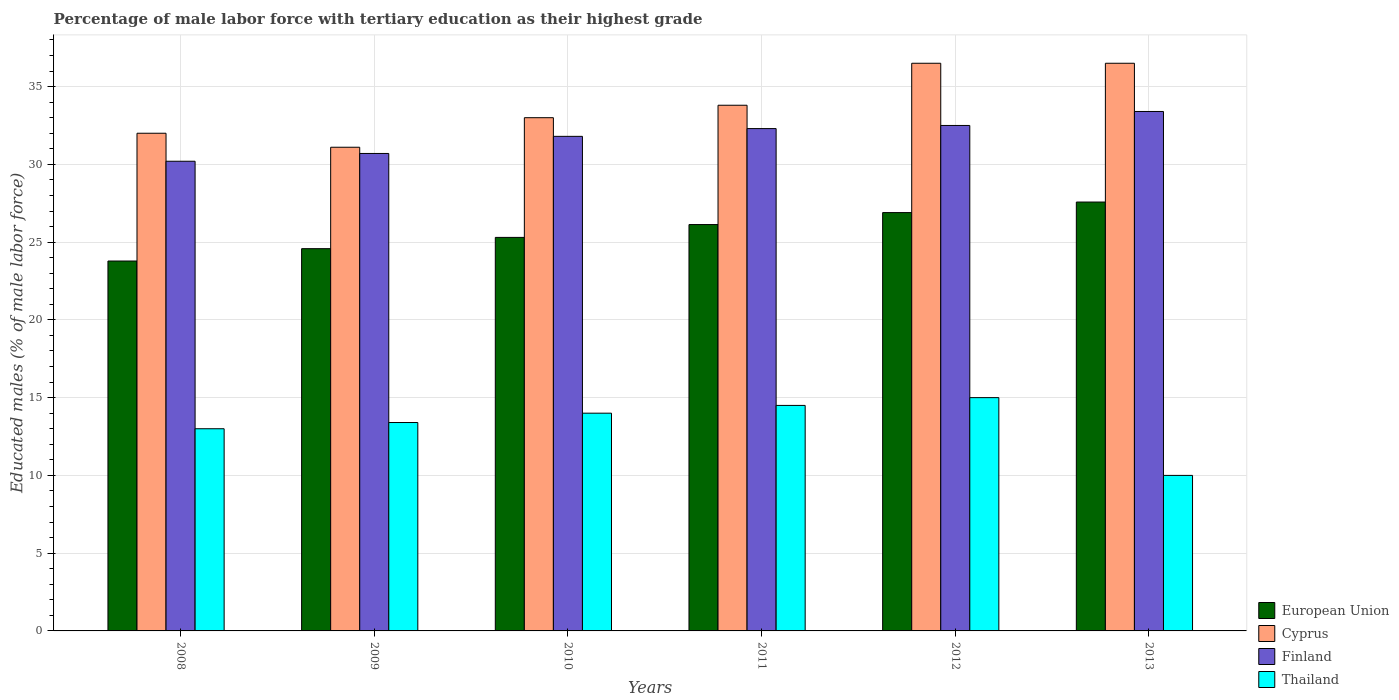How many different coloured bars are there?
Ensure brevity in your answer.  4. How many groups of bars are there?
Keep it short and to the point. 6. How many bars are there on the 1st tick from the left?
Give a very brief answer. 4. What is the percentage of male labor force with tertiary education in European Union in 2013?
Keep it short and to the point. 27.58. Across all years, what is the maximum percentage of male labor force with tertiary education in Cyprus?
Keep it short and to the point. 36.5. Across all years, what is the minimum percentage of male labor force with tertiary education in Finland?
Provide a succinct answer. 30.2. In which year was the percentage of male labor force with tertiary education in European Union minimum?
Give a very brief answer. 2008. What is the total percentage of male labor force with tertiary education in Thailand in the graph?
Keep it short and to the point. 79.9. What is the difference between the percentage of male labor force with tertiary education in Finland in 2008 and that in 2012?
Your response must be concise. -2.3. What is the difference between the percentage of male labor force with tertiary education in European Union in 2011 and the percentage of male labor force with tertiary education in Finland in 2008?
Offer a terse response. -4.07. What is the average percentage of male labor force with tertiary education in Thailand per year?
Provide a short and direct response. 13.32. In the year 2012, what is the difference between the percentage of male labor force with tertiary education in Cyprus and percentage of male labor force with tertiary education in Finland?
Offer a terse response. 4. What is the ratio of the percentage of male labor force with tertiary education in Cyprus in 2009 to that in 2013?
Your answer should be compact. 0.85. Is the percentage of male labor force with tertiary education in Finland in 2011 less than that in 2012?
Give a very brief answer. Yes. Is the difference between the percentage of male labor force with tertiary education in Cyprus in 2010 and 2011 greater than the difference between the percentage of male labor force with tertiary education in Finland in 2010 and 2011?
Offer a terse response. No. What is the difference between the highest and the second highest percentage of male labor force with tertiary education in Finland?
Your answer should be very brief. 0.9. What is the difference between the highest and the lowest percentage of male labor force with tertiary education in European Union?
Your answer should be very brief. 3.79. In how many years, is the percentage of male labor force with tertiary education in Thailand greater than the average percentage of male labor force with tertiary education in Thailand taken over all years?
Offer a very short reply. 4. What does the 4th bar from the left in 2012 represents?
Your response must be concise. Thailand. What does the 2nd bar from the right in 2010 represents?
Your response must be concise. Finland. Is it the case that in every year, the sum of the percentage of male labor force with tertiary education in Cyprus and percentage of male labor force with tertiary education in Thailand is greater than the percentage of male labor force with tertiary education in Finland?
Give a very brief answer. Yes. Are all the bars in the graph horizontal?
Your answer should be compact. No. Where does the legend appear in the graph?
Your response must be concise. Bottom right. How many legend labels are there?
Provide a short and direct response. 4. What is the title of the graph?
Offer a terse response. Percentage of male labor force with tertiary education as their highest grade. Does "Denmark" appear as one of the legend labels in the graph?
Your answer should be compact. No. What is the label or title of the X-axis?
Give a very brief answer. Years. What is the label or title of the Y-axis?
Your answer should be compact. Educated males (% of male labor force). What is the Educated males (% of male labor force) of European Union in 2008?
Give a very brief answer. 23.78. What is the Educated males (% of male labor force) in Cyprus in 2008?
Your answer should be compact. 32. What is the Educated males (% of male labor force) of Finland in 2008?
Make the answer very short. 30.2. What is the Educated males (% of male labor force) of European Union in 2009?
Give a very brief answer. 24.58. What is the Educated males (% of male labor force) in Cyprus in 2009?
Provide a short and direct response. 31.1. What is the Educated males (% of male labor force) in Finland in 2009?
Make the answer very short. 30.7. What is the Educated males (% of male labor force) in Thailand in 2009?
Provide a short and direct response. 13.4. What is the Educated males (% of male labor force) in European Union in 2010?
Keep it short and to the point. 25.3. What is the Educated males (% of male labor force) of Cyprus in 2010?
Offer a terse response. 33. What is the Educated males (% of male labor force) of Finland in 2010?
Provide a short and direct response. 31.8. What is the Educated males (% of male labor force) in Thailand in 2010?
Give a very brief answer. 14. What is the Educated males (% of male labor force) of European Union in 2011?
Your answer should be compact. 26.13. What is the Educated males (% of male labor force) in Cyprus in 2011?
Your answer should be compact. 33.8. What is the Educated males (% of male labor force) of Finland in 2011?
Keep it short and to the point. 32.3. What is the Educated males (% of male labor force) in European Union in 2012?
Offer a very short reply. 26.9. What is the Educated males (% of male labor force) in Cyprus in 2012?
Ensure brevity in your answer.  36.5. What is the Educated males (% of male labor force) of Finland in 2012?
Provide a short and direct response. 32.5. What is the Educated males (% of male labor force) in Thailand in 2012?
Offer a very short reply. 15. What is the Educated males (% of male labor force) in European Union in 2013?
Offer a very short reply. 27.58. What is the Educated males (% of male labor force) of Cyprus in 2013?
Make the answer very short. 36.5. What is the Educated males (% of male labor force) of Finland in 2013?
Offer a very short reply. 33.4. What is the Educated males (% of male labor force) of Thailand in 2013?
Ensure brevity in your answer.  10. Across all years, what is the maximum Educated males (% of male labor force) of European Union?
Provide a succinct answer. 27.58. Across all years, what is the maximum Educated males (% of male labor force) in Cyprus?
Offer a terse response. 36.5. Across all years, what is the maximum Educated males (% of male labor force) of Finland?
Make the answer very short. 33.4. Across all years, what is the maximum Educated males (% of male labor force) in Thailand?
Provide a succinct answer. 15. Across all years, what is the minimum Educated males (% of male labor force) in European Union?
Make the answer very short. 23.78. Across all years, what is the minimum Educated males (% of male labor force) in Cyprus?
Offer a terse response. 31.1. Across all years, what is the minimum Educated males (% of male labor force) in Finland?
Provide a short and direct response. 30.2. What is the total Educated males (% of male labor force) of European Union in the graph?
Give a very brief answer. 154.27. What is the total Educated males (% of male labor force) of Cyprus in the graph?
Provide a short and direct response. 202.9. What is the total Educated males (% of male labor force) of Finland in the graph?
Your answer should be very brief. 190.9. What is the total Educated males (% of male labor force) of Thailand in the graph?
Your answer should be very brief. 79.9. What is the difference between the Educated males (% of male labor force) in European Union in 2008 and that in 2009?
Offer a terse response. -0.79. What is the difference between the Educated males (% of male labor force) in Cyprus in 2008 and that in 2009?
Your response must be concise. 0.9. What is the difference between the Educated males (% of male labor force) of Finland in 2008 and that in 2009?
Your answer should be compact. -0.5. What is the difference between the Educated males (% of male labor force) of Thailand in 2008 and that in 2009?
Offer a very short reply. -0.4. What is the difference between the Educated males (% of male labor force) of European Union in 2008 and that in 2010?
Your answer should be very brief. -1.52. What is the difference between the Educated males (% of male labor force) in Thailand in 2008 and that in 2010?
Your response must be concise. -1. What is the difference between the Educated males (% of male labor force) of European Union in 2008 and that in 2011?
Your response must be concise. -2.34. What is the difference between the Educated males (% of male labor force) of European Union in 2008 and that in 2012?
Offer a very short reply. -3.11. What is the difference between the Educated males (% of male labor force) in Cyprus in 2008 and that in 2012?
Offer a very short reply. -4.5. What is the difference between the Educated males (% of male labor force) of European Union in 2008 and that in 2013?
Your response must be concise. -3.79. What is the difference between the Educated males (% of male labor force) in Thailand in 2008 and that in 2013?
Offer a terse response. 3. What is the difference between the Educated males (% of male labor force) of European Union in 2009 and that in 2010?
Give a very brief answer. -0.72. What is the difference between the Educated males (% of male labor force) in Finland in 2009 and that in 2010?
Your answer should be compact. -1.1. What is the difference between the Educated males (% of male labor force) in Thailand in 2009 and that in 2010?
Your answer should be very brief. -0.6. What is the difference between the Educated males (% of male labor force) of European Union in 2009 and that in 2011?
Ensure brevity in your answer.  -1.55. What is the difference between the Educated males (% of male labor force) of Cyprus in 2009 and that in 2011?
Your answer should be very brief. -2.7. What is the difference between the Educated males (% of male labor force) in Finland in 2009 and that in 2011?
Offer a terse response. -1.6. What is the difference between the Educated males (% of male labor force) of European Union in 2009 and that in 2012?
Ensure brevity in your answer.  -2.32. What is the difference between the Educated males (% of male labor force) in Cyprus in 2009 and that in 2012?
Provide a succinct answer. -5.4. What is the difference between the Educated males (% of male labor force) in Finland in 2009 and that in 2012?
Your answer should be very brief. -1.8. What is the difference between the Educated males (% of male labor force) of Thailand in 2009 and that in 2012?
Offer a very short reply. -1.6. What is the difference between the Educated males (% of male labor force) in European Union in 2009 and that in 2013?
Provide a short and direct response. -3. What is the difference between the Educated males (% of male labor force) in European Union in 2010 and that in 2011?
Give a very brief answer. -0.83. What is the difference between the Educated males (% of male labor force) of Finland in 2010 and that in 2011?
Your answer should be compact. -0.5. What is the difference between the Educated males (% of male labor force) in Thailand in 2010 and that in 2011?
Ensure brevity in your answer.  -0.5. What is the difference between the Educated males (% of male labor force) in European Union in 2010 and that in 2012?
Offer a terse response. -1.6. What is the difference between the Educated males (% of male labor force) in Cyprus in 2010 and that in 2012?
Your response must be concise. -3.5. What is the difference between the Educated males (% of male labor force) of Finland in 2010 and that in 2012?
Your answer should be very brief. -0.7. What is the difference between the Educated males (% of male labor force) of Thailand in 2010 and that in 2012?
Your answer should be very brief. -1. What is the difference between the Educated males (% of male labor force) of European Union in 2010 and that in 2013?
Make the answer very short. -2.27. What is the difference between the Educated males (% of male labor force) in Cyprus in 2010 and that in 2013?
Offer a terse response. -3.5. What is the difference between the Educated males (% of male labor force) of European Union in 2011 and that in 2012?
Your answer should be compact. -0.77. What is the difference between the Educated males (% of male labor force) of Finland in 2011 and that in 2012?
Your response must be concise. -0.2. What is the difference between the Educated males (% of male labor force) of European Union in 2011 and that in 2013?
Provide a short and direct response. -1.45. What is the difference between the Educated males (% of male labor force) in Finland in 2011 and that in 2013?
Give a very brief answer. -1.1. What is the difference between the Educated males (% of male labor force) in European Union in 2012 and that in 2013?
Your response must be concise. -0.68. What is the difference between the Educated males (% of male labor force) of Cyprus in 2012 and that in 2013?
Give a very brief answer. 0. What is the difference between the Educated males (% of male labor force) in Finland in 2012 and that in 2013?
Ensure brevity in your answer.  -0.9. What is the difference between the Educated males (% of male labor force) of European Union in 2008 and the Educated males (% of male labor force) of Cyprus in 2009?
Keep it short and to the point. -7.32. What is the difference between the Educated males (% of male labor force) of European Union in 2008 and the Educated males (% of male labor force) of Finland in 2009?
Your answer should be very brief. -6.92. What is the difference between the Educated males (% of male labor force) in European Union in 2008 and the Educated males (% of male labor force) in Thailand in 2009?
Your answer should be very brief. 10.38. What is the difference between the Educated males (% of male labor force) of Finland in 2008 and the Educated males (% of male labor force) of Thailand in 2009?
Ensure brevity in your answer.  16.8. What is the difference between the Educated males (% of male labor force) of European Union in 2008 and the Educated males (% of male labor force) of Cyprus in 2010?
Give a very brief answer. -9.22. What is the difference between the Educated males (% of male labor force) of European Union in 2008 and the Educated males (% of male labor force) of Finland in 2010?
Provide a short and direct response. -8.02. What is the difference between the Educated males (% of male labor force) in European Union in 2008 and the Educated males (% of male labor force) in Thailand in 2010?
Your response must be concise. 9.78. What is the difference between the Educated males (% of male labor force) in Cyprus in 2008 and the Educated males (% of male labor force) in Finland in 2010?
Offer a terse response. 0.2. What is the difference between the Educated males (% of male labor force) in Cyprus in 2008 and the Educated males (% of male labor force) in Thailand in 2010?
Your answer should be compact. 18. What is the difference between the Educated males (% of male labor force) of Finland in 2008 and the Educated males (% of male labor force) of Thailand in 2010?
Give a very brief answer. 16.2. What is the difference between the Educated males (% of male labor force) of European Union in 2008 and the Educated males (% of male labor force) of Cyprus in 2011?
Ensure brevity in your answer.  -10.02. What is the difference between the Educated males (% of male labor force) in European Union in 2008 and the Educated males (% of male labor force) in Finland in 2011?
Give a very brief answer. -8.52. What is the difference between the Educated males (% of male labor force) of European Union in 2008 and the Educated males (% of male labor force) of Thailand in 2011?
Your response must be concise. 9.28. What is the difference between the Educated males (% of male labor force) in Cyprus in 2008 and the Educated males (% of male labor force) in Finland in 2011?
Your answer should be very brief. -0.3. What is the difference between the Educated males (% of male labor force) in Cyprus in 2008 and the Educated males (% of male labor force) in Thailand in 2011?
Your answer should be compact. 17.5. What is the difference between the Educated males (% of male labor force) of Finland in 2008 and the Educated males (% of male labor force) of Thailand in 2011?
Ensure brevity in your answer.  15.7. What is the difference between the Educated males (% of male labor force) in European Union in 2008 and the Educated males (% of male labor force) in Cyprus in 2012?
Your answer should be compact. -12.72. What is the difference between the Educated males (% of male labor force) of European Union in 2008 and the Educated males (% of male labor force) of Finland in 2012?
Your response must be concise. -8.72. What is the difference between the Educated males (% of male labor force) of European Union in 2008 and the Educated males (% of male labor force) of Thailand in 2012?
Offer a terse response. 8.78. What is the difference between the Educated males (% of male labor force) in Finland in 2008 and the Educated males (% of male labor force) in Thailand in 2012?
Your answer should be compact. 15.2. What is the difference between the Educated males (% of male labor force) of European Union in 2008 and the Educated males (% of male labor force) of Cyprus in 2013?
Your answer should be very brief. -12.72. What is the difference between the Educated males (% of male labor force) in European Union in 2008 and the Educated males (% of male labor force) in Finland in 2013?
Provide a succinct answer. -9.62. What is the difference between the Educated males (% of male labor force) of European Union in 2008 and the Educated males (% of male labor force) of Thailand in 2013?
Ensure brevity in your answer.  13.78. What is the difference between the Educated males (% of male labor force) of Cyprus in 2008 and the Educated males (% of male labor force) of Finland in 2013?
Ensure brevity in your answer.  -1.4. What is the difference between the Educated males (% of male labor force) in Cyprus in 2008 and the Educated males (% of male labor force) in Thailand in 2013?
Your answer should be compact. 22. What is the difference between the Educated males (% of male labor force) in Finland in 2008 and the Educated males (% of male labor force) in Thailand in 2013?
Keep it short and to the point. 20.2. What is the difference between the Educated males (% of male labor force) of European Union in 2009 and the Educated males (% of male labor force) of Cyprus in 2010?
Ensure brevity in your answer.  -8.42. What is the difference between the Educated males (% of male labor force) of European Union in 2009 and the Educated males (% of male labor force) of Finland in 2010?
Give a very brief answer. -7.22. What is the difference between the Educated males (% of male labor force) of European Union in 2009 and the Educated males (% of male labor force) of Thailand in 2010?
Provide a succinct answer. 10.58. What is the difference between the Educated males (% of male labor force) in European Union in 2009 and the Educated males (% of male labor force) in Cyprus in 2011?
Provide a succinct answer. -9.22. What is the difference between the Educated males (% of male labor force) of European Union in 2009 and the Educated males (% of male labor force) of Finland in 2011?
Offer a terse response. -7.72. What is the difference between the Educated males (% of male labor force) of European Union in 2009 and the Educated males (% of male labor force) of Thailand in 2011?
Offer a terse response. 10.08. What is the difference between the Educated males (% of male labor force) of Cyprus in 2009 and the Educated males (% of male labor force) of Thailand in 2011?
Your response must be concise. 16.6. What is the difference between the Educated males (% of male labor force) of Finland in 2009 and the Educated males (% of male labor force) of Thailand in 2011?
Provide a succinct answer. 16.2. What is the difference between the Educated males (% of male labor force) of European Union in 2009 and the Educated males (% of male labor force) of Cyprus in 2012?
Your answer should be compact. -11.92. What is the difference between the Educated males (% of male labor force) in European Union in 2009 and the Educated males (% of male labor force) in Finland in 2012?
Ensure brevity in your answer.  -7.92. What is the difference between the Educated males (% of male labor force) of European Union in 2009 and the Educated males (% of male labor force) of Thailand in 2012?
Provide a short and direct response. 9.58. What is the difference between the Educated males (% of male labor force) of Cyprus in 2009 and the Educated males (% of male labor force) of Finland in 2012?
Provide a short and direct response. -1.4. What is the difference between the Educated males (% of male labor force) of Finland in 2009 and the Educated males (% of male labor force) of Thailand in 2012?
Make the answer very short. 15.7. What is the difference between the Educated males (% of male labor force) in European Union in 2009 and the Educated males (% of male labor force) in Cyprus in 2013?
Keep it short and to the point. -11.92. What is the difference between the Educated males (% of male labor force) of European Union in 2009 and the Educated males (% of male labor force) of Finland in 2013?
Offer a very short reply. -8.82. What is the difference between the Educated males (% of male labor force) in European Union in 2009 and the Educated males (% of male labor force) in Thailand in 2013?
Offer a very short reply. 14.58. What is the difference between the Educated males (% of male labor force) in Cyprus in 2009 and the Educated males (% of male labor force) in Finland in 2013?
Provide a short and direct response. -2.3. What is the difference between the Educated males (% of male labor force) in Cyprus in 2009 and the Educated males (% of male labor force) in Thailand in 2013?
Offer a terse response. 21.1. What is the difference between the Educated males (% of male labor force) of Finland in 2009 and the Educated males (% of male labor force) of Thailand in 2013?
Give a very brief answer. 20.7. What is the difference between the Educated males (% of male labor force) of European Union in 2010 and the Educated males (% of male labor force) of Cyprus in 2011?
Offer a very short reply. -8.5. What is the difference between the Educated males (% of male labor force) in European Union in 2010 and the Educated males (% of male labor force) in Finland in 2011?
Offer a very short reply. -7. What is the difference between the Educated males (% of male labor force) in European Union in 2010 and the Educated males (% of male labor force) in Thailand in 2011?
Your answer should be compact. 10.8. What is the difference between the Educated males (% of male labor force) in Cyprus in 2010 and the Educated males (% of male labor force) in Finland in 2011?
Provide a short and direct response. 0.7. What is the difference between the Educated males (% of male labor force) in Cyprus in 2010 and the Educated males (% of male labor force) in Thailand in 2011?
Offer a very short reply. 18.5. What is the difference between the Educated males (% of male labor force) of Finland in 2010 and the Educated males (% of male labor force) of Thailand in 2011?
Your answer should be compact. 17.3. What is the difference between the Educated males (% of male labor force) in European Union in 2010 and the Educated males (% of male labor force) in Cyprus in 2012?
Your response must be concise. -11.2. What is the difference between the Educated males (% of male labor force) in European Union in 2010 and the Educated males (% of male labor force) in Finland in 2012?
Provide a succinct answer. -7.2. What is the difference between the Educated males (% of male labor force) of European Union in 2010 and the Educated males (% of male labor force) of Thailand in 2012?
Provide a succinct answer. 10.3. What is the difference between the Educated males (% of male labor force) in Cyprus in 2010 and the Educated males (% of male labor force) in Finland in 2012?
Your answer should be very brief. 0.5. What is the difference between the Educated males (% of male labor force) of Finland in 2010 and the Educated males (% of male labor force) of Thailand in 2012?
Give a very brief answer. 16.8. What is the difference between the Educated males (% of male labor force) of European Union in 2010 and the Educated males (% of male labor force) of Cyprus in 2013?
Your response must be concise. -11.2. What is the difference between the Educated males (% of male labor force) of European Union in 2010 and the Educated males (% of male labor force) of Finland in 2013?
Offer a terse response. -8.1. What is the difference between the Educated males (% of male labor force) in European Union in 2010 and the Educated males (% of male labor force) in Thailand in 2013?
Ensure brevity in your answer.  15.3. What is the difference between the Educated males (% of male labor force) of Cyprus in 2010 and the Educated males (% of male labor force) of Finland in 2013?
Keep it short and to the point. -0.4. What is the difference between the Educated males (% of male labor force) in Cyprus in 2010 and the Educated males (% of male labor force) in Thailand in 2013?
Offer a very short reply. 23. What is the difference between the Educated males (% of male labor force) in Finland in 2010 and the Educated males (% of male labor force) in Thailand in 2013?
Give a very brief answer. 21.8. What is the difference between the Educated males (% of male labor force) in European Union in 2011 and the Educated males (% of male labor force) in Cyprus in 2012?
Give a very brief answer. -10.37. What is the difference between the Educated males (% of male labor force) of European Union in 2011 and the Educated males (% of male labor force) of Finland in 2012?
Provide a succinct answer. -6.37. What is the difference between the Educated males (% of male labor force) of European Union in 2011 and the Educated males (% of male labor force) of Thailand in 2012?
Provide a succinct answer. 11.13. What is the difference between the Educated males (% of male labor force) in Cyprus in 2011 and the Educated males (% of male labor force) in Finland in 2012?
Ensure brevity in your answer.  1.3. What is the difference between the Educated males (% of male labor force) of European Union in 2011 and the Educated males (% of male labor force) of Cyprus in 2013?
Your answer should be very brief. -10.37. What is the difference between the Educated males (% of male labor force) of European Union in 2011 and the Educated males (% of male labor force) of Finland in 2013?
Ensure brevity in your answer.  -7.27. What is the difference between the Educated males (% of male labor force) in European Union in 2011 and the Educated males (% of male labor force) in Thailand in 2013?
Offer a very short reply. 16.13. What is the difference between the Educated males (% of male labor force) of Cyprus in 2011 and the Educated males (% of male labor force) of Finland in 2013?
Ensure brevity in your answer.  0.4. What is the difference between the Educated males (% of male labor force) in Cyprus in 2011 and the Educated males (% of male labor force) in Thailand in 2013?
Offer a terse response. 23.8. What is the difference between the Educated males (% of male labor force) in Finland in 2011 and the Educated males (% of male labor force) in Thailand in 2013?
Your response must be concise. 22.3. What is the difference between the Educated males (% of male labor force) in European Union in 2012 and the Educated males (% of male labor force) in Cyprus in 2013?
Your response must be concise. -9.6. What is the difference between the Educated males (% of male labor force) of European Union in 2012 and the Educated males (% of male labor force) of Finland in 2013?
Your answer should be very brief. -6.5. What is the difference between the Educated males (% of male labor force) of European Union in 2012 and the Educated males (% of male labor force) of Thailand in 2013?
Keep it short and to the point. 16.9. What is the difference between the Educated males (% of male labor force) in Cyprus in 2012 and the Educated males (% of male labor force) in Finland in 2013?
Your answer should be very brief. 3.1. What is the difference between the Educated males (% of male labor force) of Finland in 2012 and the Educated males (% of male labor force) of Thailand in 2013?
Give a very brief answer. 22.5. What is the average Educated males (% of male labor force) of European Union per year?
Make the answer very short. 25.71. What is the average Educated males (% of male labor force) in Cyprus per year?
Offer a terse response. 33.82. What is the average Educated males (% of male labor force) in Finland per year?
Provide a succinct answer. 31.82. What is the average Educated males (% of male labor force) of Thailand per year?
Provide a short and direct response. 13.32. In the year 2008, what is the difference between the Educated males (% of male labor force) of European Union and Educated males (% of male labor force) of Cyprus?
Your response must be concise. -8.22. In the year 2008, what is the difference between the Educated males (% of male labor force) of European Union and Educated males (% of male labor force) of Finland?
Provide a short and direct response. -6.42. In the year 2008, what is the difference between the Educated males (% of male labor force) of European Union and Educated males (% of male labor force) of Thailand?
Offer a very short reply. 10.78. In the year 2009, what is the difference between the Educated males (% of male labor force) of European Union and Educated males (% of male labor force) of Cyprus?
Give a very brief answer. -6.52. In the year 2009, what is the difference between the Educated males (% of male labor force) of European Union and Educated males (% of male labor force) of Finland?
Make the answer very short. -6.12. In the year 2009, what is the difference between the Educated males (% of male labor force) of European Union and Educated males (% of male labor force) of Thailand?
Your answer should be very brief. 11.18. In the year 2009, what is the difference between the Educated males (% of male labor force) in Cyprus and Educated males (% of male labor force) in Thailand?
Give a very brief answer. 17.7. In the year 2009, what is the difference between the Educated males (% of male labor force) in Finland and Educated males (% of male labor force) in Thailand?
Ensure brevity in your answer.  17.3. In the year 2010, what is the difference between the Educated males (% of male labor force) in European Union and Educated males (% of male labor force) in Cyprus?
Make the answer very short. -7.7. In the year 2010, what is the difference between the Educated males (% of male labor force) of European Union and Educated males (% of male labor force) of Finland?
Your answer should be very brief. -6.5. In the year 2010, what is the difference between the Educated males (% of male labor force) of European Union and Educated males (% of male labor force) of Thailand?
Offer a terse response. 11.3. In the year 2010, what is the difference between the Educated males (% of male labor force) in Finland and Educated males (% of male labor force) in Thailand?
Your answer should be very brief. 17.8. In the year 2011, what is the difference between the Educated males (% of male labor force) of European Union and Educated males (% of male labor force) of Cyprus?
Provide a short and direct response. -7.67. In the year 2011, what is the difference between the Educated males (% of male labor force) in European Union and Educated males (% of male labor force) in Finland?
Your response must be concise. -6.17. In the year 2011, what is the difference between the Educated males (% of male labor force) in European Union and Educated males (% of male labor force) in Thailand?
Provide a short and direct response. 11.63. In the year 2011, what is the difference between the Educated males (% of male labor force) of Cyprus and Educated males (% of male labor force) of Thailand?
Make the answer very short. 19.3. In the year 2012, what is the difference between the Educated males (% of male labor force) of European Union and Educated males (% of male labor force) of Cyprus?
Your answer should be very brief. -9.6. In the year 2012, what is the difference between the Educated males (% of male labor force) in European Union and Educated males (% of male labor force) in Finland?
Your response must be concise. -5.6. In the year 2012, what is the difference between the Educated males (% of male labor force) in European Union and Educated males (% of male labor force) in Thailand?
Offer a terse response. 11.9. In the year 2012, what is the difference between the Educated males (% of male labor force) of Cyprus and Educated males (% of male labor force) of Finland?
Offer a very short reply. 4. In the year 2012, what is the difference between the Educated males (% of male labor force) of Cyprus and Educated males (% of male labor force) of Thailand?
Keep it short and to the point. 21.5. In the year 2012, what is the difference between the Educated males (% of male labor force) in Finland and Educated males (% of male labor force) in Thailand?
Your answer should be compact. 17.5. In the year 2013, what is the difference between the Educated males (% of male labor force) in European Union and Educated males (% of male labor force) in Cyprus?
Provide a short and direct response. -8.92. In the year 2013, what is the difference between the Educated males (% of male labor force) of European Union and Educated males (% of male labor force) of Finland?
Provide a short and direct response. -5.82. In the year 2013, what is the difference between the Educated males (% of male labor force) of European Union and Educated males (% of male labor force) of Thailand?
Ensure brevity in your answer.  17.58. In the year 2013, what is the difference between the Educated males (% of male labor force) in Finland and Educated males (% of male labor force) in Thailand?
Provide a succinct answer. 23.4. What is the ratio of the Educated males (% of male labor force) in Cyprus in 2008 to that in 2009?
Provide a short and direct response. 1.03. What is the ratio of the Educated males (% of male labor force) in Finland in 2008 to that in 2009?
Ensure brevity in your answer.  0.98. What is the ratio of the Educated males (% of male labor force) in Thailand in 2008 to that in 2009?
Provide a short and direct response. 0.97. What is the ratio of the Educated males (% of male labor force) of Cyprus in 2008 to that in 2010?
Offer a very short reply. 0.97. What is the ratio of the Educated males (% of male labor force) in Finland in 2008 to that in 2010?
Your answer should be compact. 0.95. What is the ratio of the Educated males (% of male labor force) of European Union in 2008 to that in 2011?
Keep it short and to the point. 0.91. What is the ratio of the Educated males (% of male labor force) in Cyprus in 2008 to that in 2011?
Provide a succinct answer. 0.95. What is the ratio of the Educated males (% of male labor force) in Finland in 2008 to that in 2011?
Your answer should be compact. 0.94. What is the ratio of the Educated males (% of male labor force) in Thailand in 2008 to that in 2011?
Ensure brevity in your answer.  0.9. What is the ratio of the Educated males (% of male labor force) in European Union in 2008 to that in 2012?
Your answer should be very brief. 0.88. What is the ratio of the Educated males (% of male labor force) in Cyprus in 2008 to that in 2012?
Offer a very short reply. 0.88. What is the ratio of the Educated males (% of male labor force) in Finland in 2008 to that in 2012?
Your answer should be compact. 0.93. What is the ratio of the Educated males (% of male labor force) of Thailand in 2008 to that in 2012?
Your response must be concise. 0.87. What is the ratio of the Educated males (% of male labor force) of European Union in 2008 to that in 2013?
Provide a short and direct response. 0.86. What is the ratio of the Educated males (% of male labor force) in Cyprus in 2008 to that in 2013?
Make the answer very short. 0.88. What is the ratio of the Educated males (% of male labor force) in Finland in 2008 to that in 2013?
Your answer should be compact. 0.9. What is the ratio of the Educated males (% of male labor force) in European Union in 2009 to that in 2010?
Offer a terse response. 0.97. What is the ratio of the Educated males (% of male labor force) of Cyprus in 2009 to that in 2010?
Keep it short and to the point. 0.94. What is the ratio of the Educated males (% of male labor force) in Finland in 2009 to that in 2010?
Offer a terse response. 0.97. What is the ratio of the Educated males (% of male labor force) of Thailand in 2009 to that in 2010?
Offer a very short reply. 0.96. What is the ratio of the Educated males (% of male labor force) in European Union in 2009 to that in 2011?
Your answer should be very brief. 0.94. What is the ratio of the Educated males (% of male labor force) in Cyprus in 2009 to that in 2011?
Provide a short and direct response. 0.92. What is the ratio of the Educated males (% of male labor force) of Finland in 2009 to that in 2011?
Ensure brevity in your answer.  0.95. What is the ratio of the Educated males (% of male labor force) in Thailand in 2009 to that in 2011?
Provide a short and direct response. 0.92. What is the ratio of the Educated males (% of male labor force) in European Union in 2009 to that in 2012?
Your response must be concise. 0.91. What is the ratio of the Educated males (% of male labor force) in Cyprus in 2009 to that in 2012?
Offer a terse response. 0.85. What is the ratio of the Educated males (% of male labor force) of Finland in 2009 to that in 2012?
Provide a short and direct response. 0.94. What is the ratio of the Educated males (% of male labor force) of Thailand in 2009 to that in 2012?
Ensure brevity in your answer.  0.89. What is the ratio of the Educated males (% of male labor force) in European Union in 2009 to that in 2013?
Offer a terse response. 0.89. What is the ratio of the Educated males (% of male labor force) of Cyprus in 2009 to that in 2013?
Offer a terse response. 0.85. What is the ratio of the Educated males (% of male labor force) of Finland in 2009 to that in 2013?
Provide a short and direct response. 0.92. What is the ratio of the Educated males (% of male labor force) in Thailand in 2009 to that in 2013?
Offer a very short reply. 1.34. What is the ratio of the Educated males (% of male labor force) of European Union in 2010 to that in 2011?
Offer a very short reply. 0.97. What is the ratio of the Educated males (% of male labor force) of Cyprus in 2010 to that in 2011?
Provide a short and direct response. 0.98. What is the ratio of the Educated males (% of male labor force) of Finland in 2010 to that in 2011?
Your response must be concise. 0.98. What is the ratio of the Educated males (% of male labor force) of Thailand in 2010 to that in 2011?
Offer a terse response. 0.97. What is the ratio of the Educated males (% of male labor force) of European Union in 2010 to that in 2012?
Keep it short and to the point. 0.94. What is the ratio of the Educated males (% of male labor force) in Cyprus in 2010 to that in 2012?
Provide a short and direct response. 0.9. What is the ratio of the Educated males (% of male labor force) in Finland in 2010 to that in 2012?
Keep it short and to the point. 0.98. What is the ratio of the Educated males (% of male labor force) of European Union in 2010 to that in 2013?
Your answer should be very brief. 0.92. What is the ratio of the Educated males (% of male labor force) in Cyprus in 2010 to that in 2013?
Your response must be concise. 0.9. What is the ratio of the Educated males (% of male labor force) of Finland in 2010 to that in 2013?
Provide a succinct answer. 0.95. What is the ratio of the Educated males (% of male labor force) in European Union in 2011 to that in 2012?
Provide a succinct answer. 0.97. What is the ratio of the Educated males (% of male labor force) of Cyprus in 2011 to that in 2012?
Provide a succinct answer. 0.93. What is the ratio of the Educated males (% of male labor force) of Thailand in 2011 to that in 2012?
Provide a short and direct response. 0.97. What is the ratio of the Educated males (% of male labor force) in European Union in 2011 to that in 2013?
Your answer should be compact. 0.95. What is the ratio of the Educated males (% of male labor force) in Cyprus in 2011 to that in 2013?
Offer a very short reply. 0.93. What is the ratio of the Educated males (% of male labor force) of Finland in 2011 to that in 2013?
Make the answer very short. 0.97. What is the ratio of the Educated males (% of male labor force) in Thailand in 2011 to that in 2013?
Offer a very short reply. 1.45. What is the ratio of the Educated males (% of male labor force) of European Union in 2012 to that in 2013?
Your answer should be very brief. 0.98. What is the ratio of the Educated males (% of male labor force) in Cyprus in 2012 to that in 2013?
Make the answer very short. 1. What is the ratio of the Educated males (% of male labor force) of Finland in 2012 to that in 2013?
Make the answer very short. 0.97. What is the difference between the highest and the second highest Educated males (% of male labor force) in European Union?
Provide a succinct answer. 0.68. What is the difference between the highest and the second highest Educated males (% of male labor force) in Cyprus?
Offer a very short reply. 0. What is the difference between the highest and the second highest Educated males (% of male labor force) in Thailand?
Your response must be concise. 0.5. What is the difference between the highest and the lowest Educated males (% of male labor force) in European Union?
Your answer should be very brief. 3.79. 